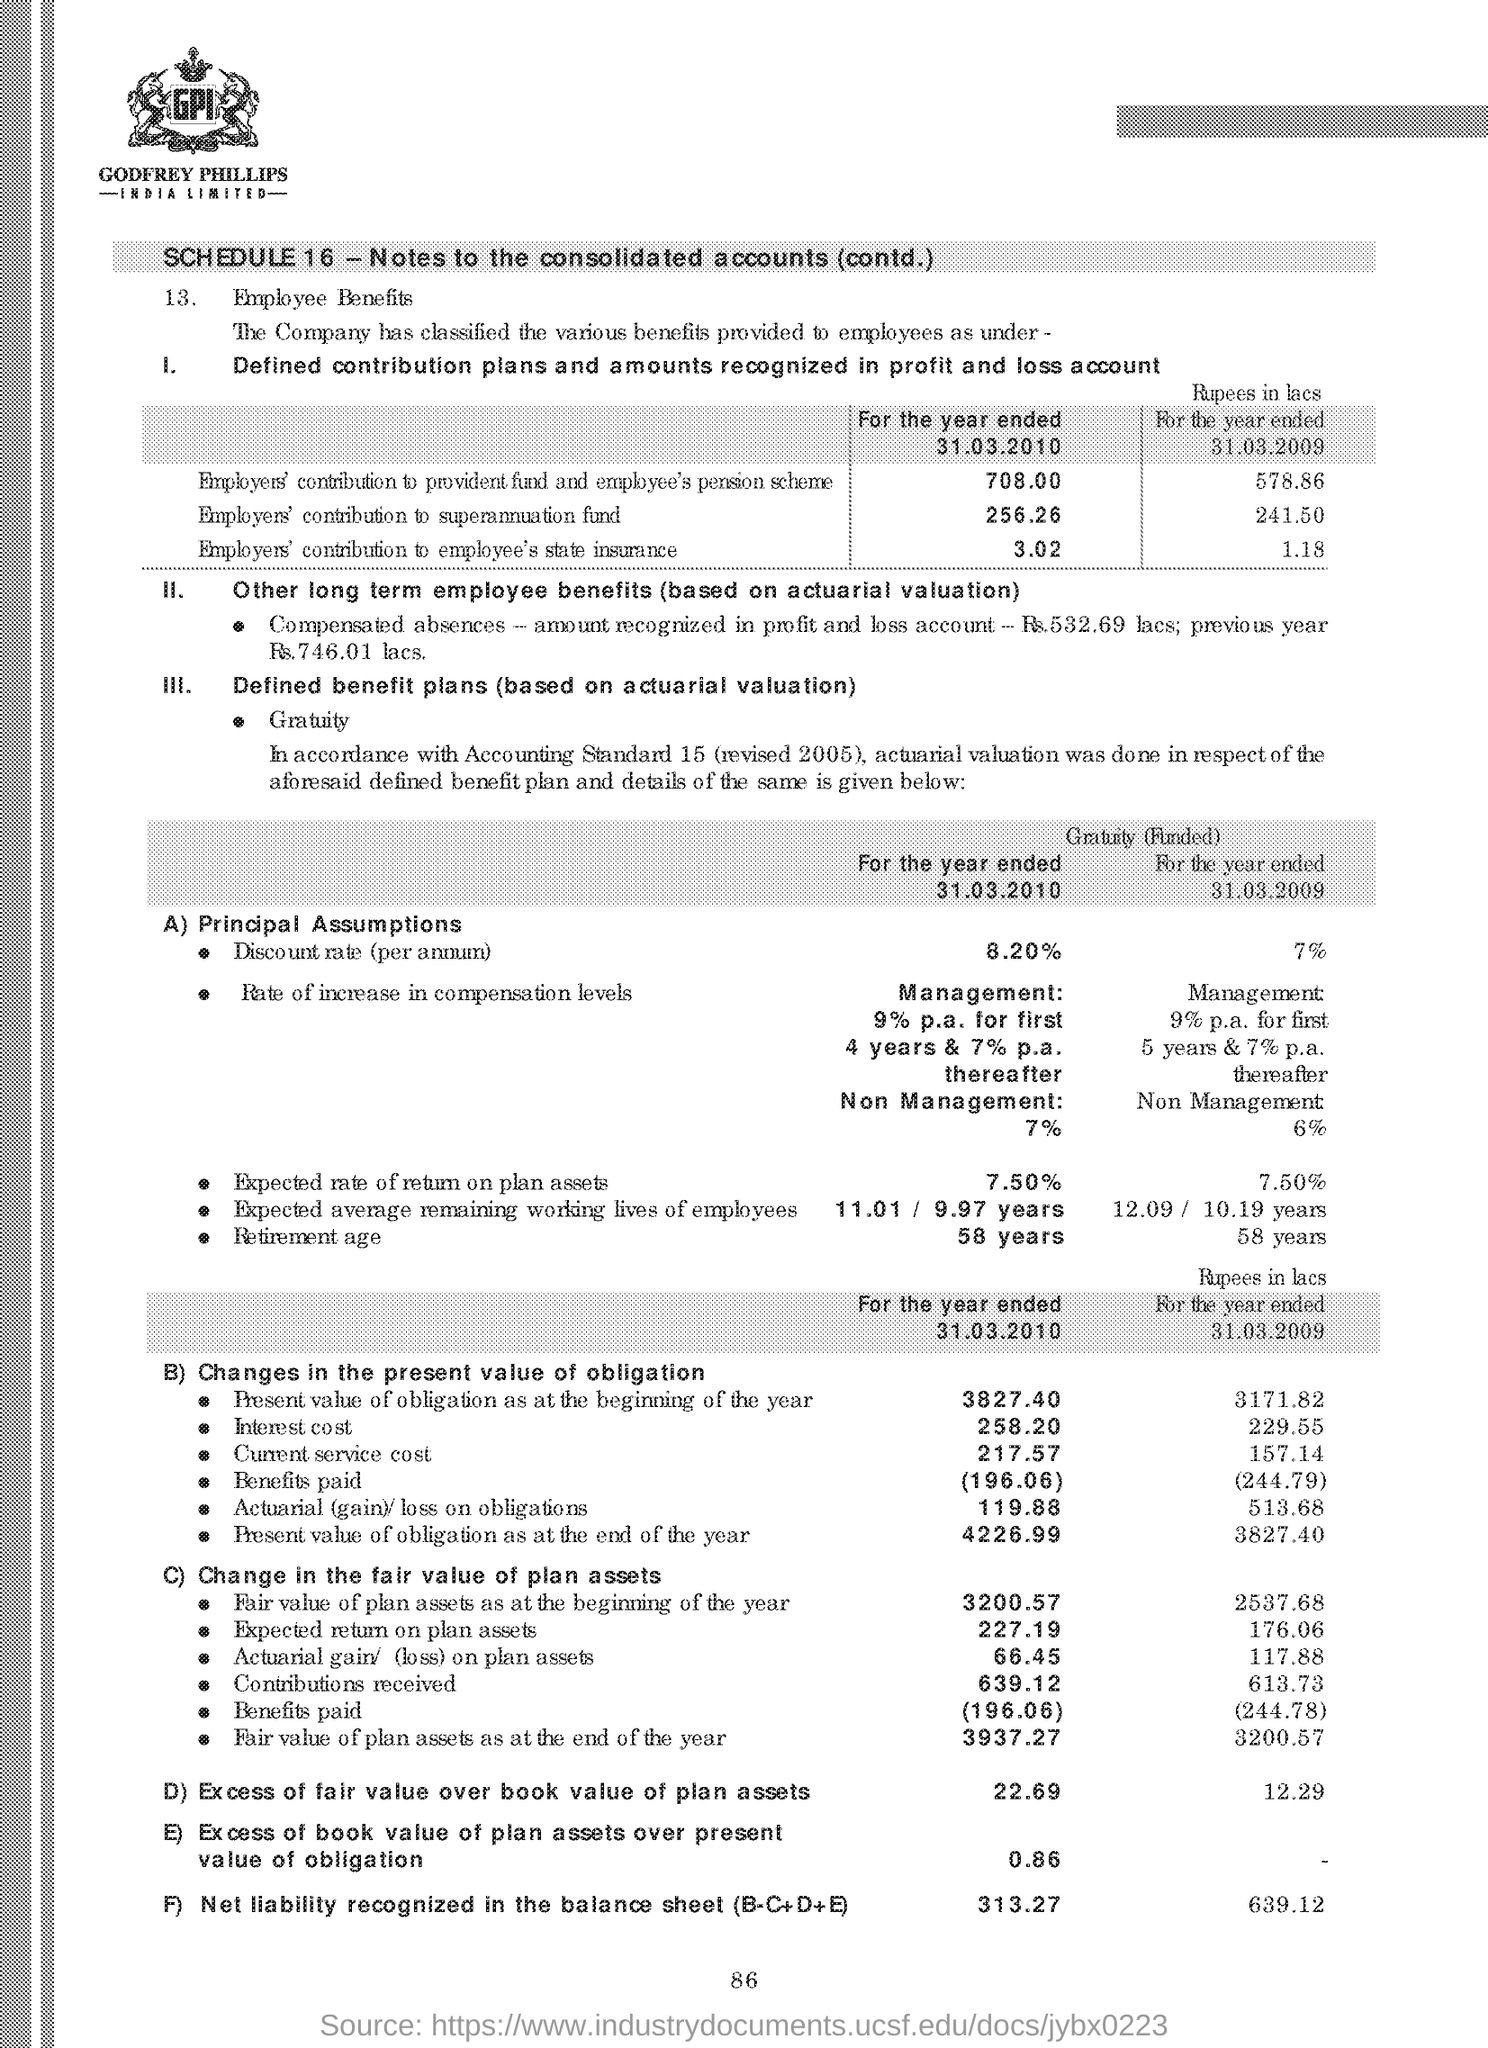List a handful of essential elements in this visual. The document mentions a schedule in the first line, and the number of the schedule is 16. The heading of point A states the principal assumptions. 